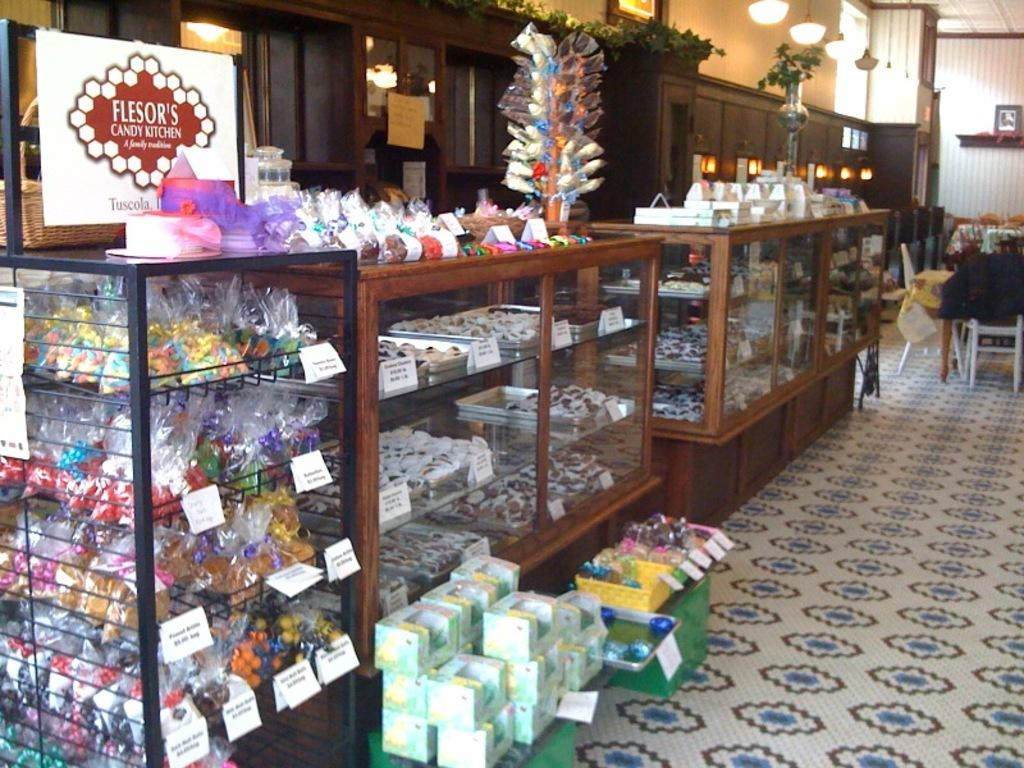<image>
Describe the image concisely. A candy stand with a sign for Flesor's Candy Kitchen above it. 